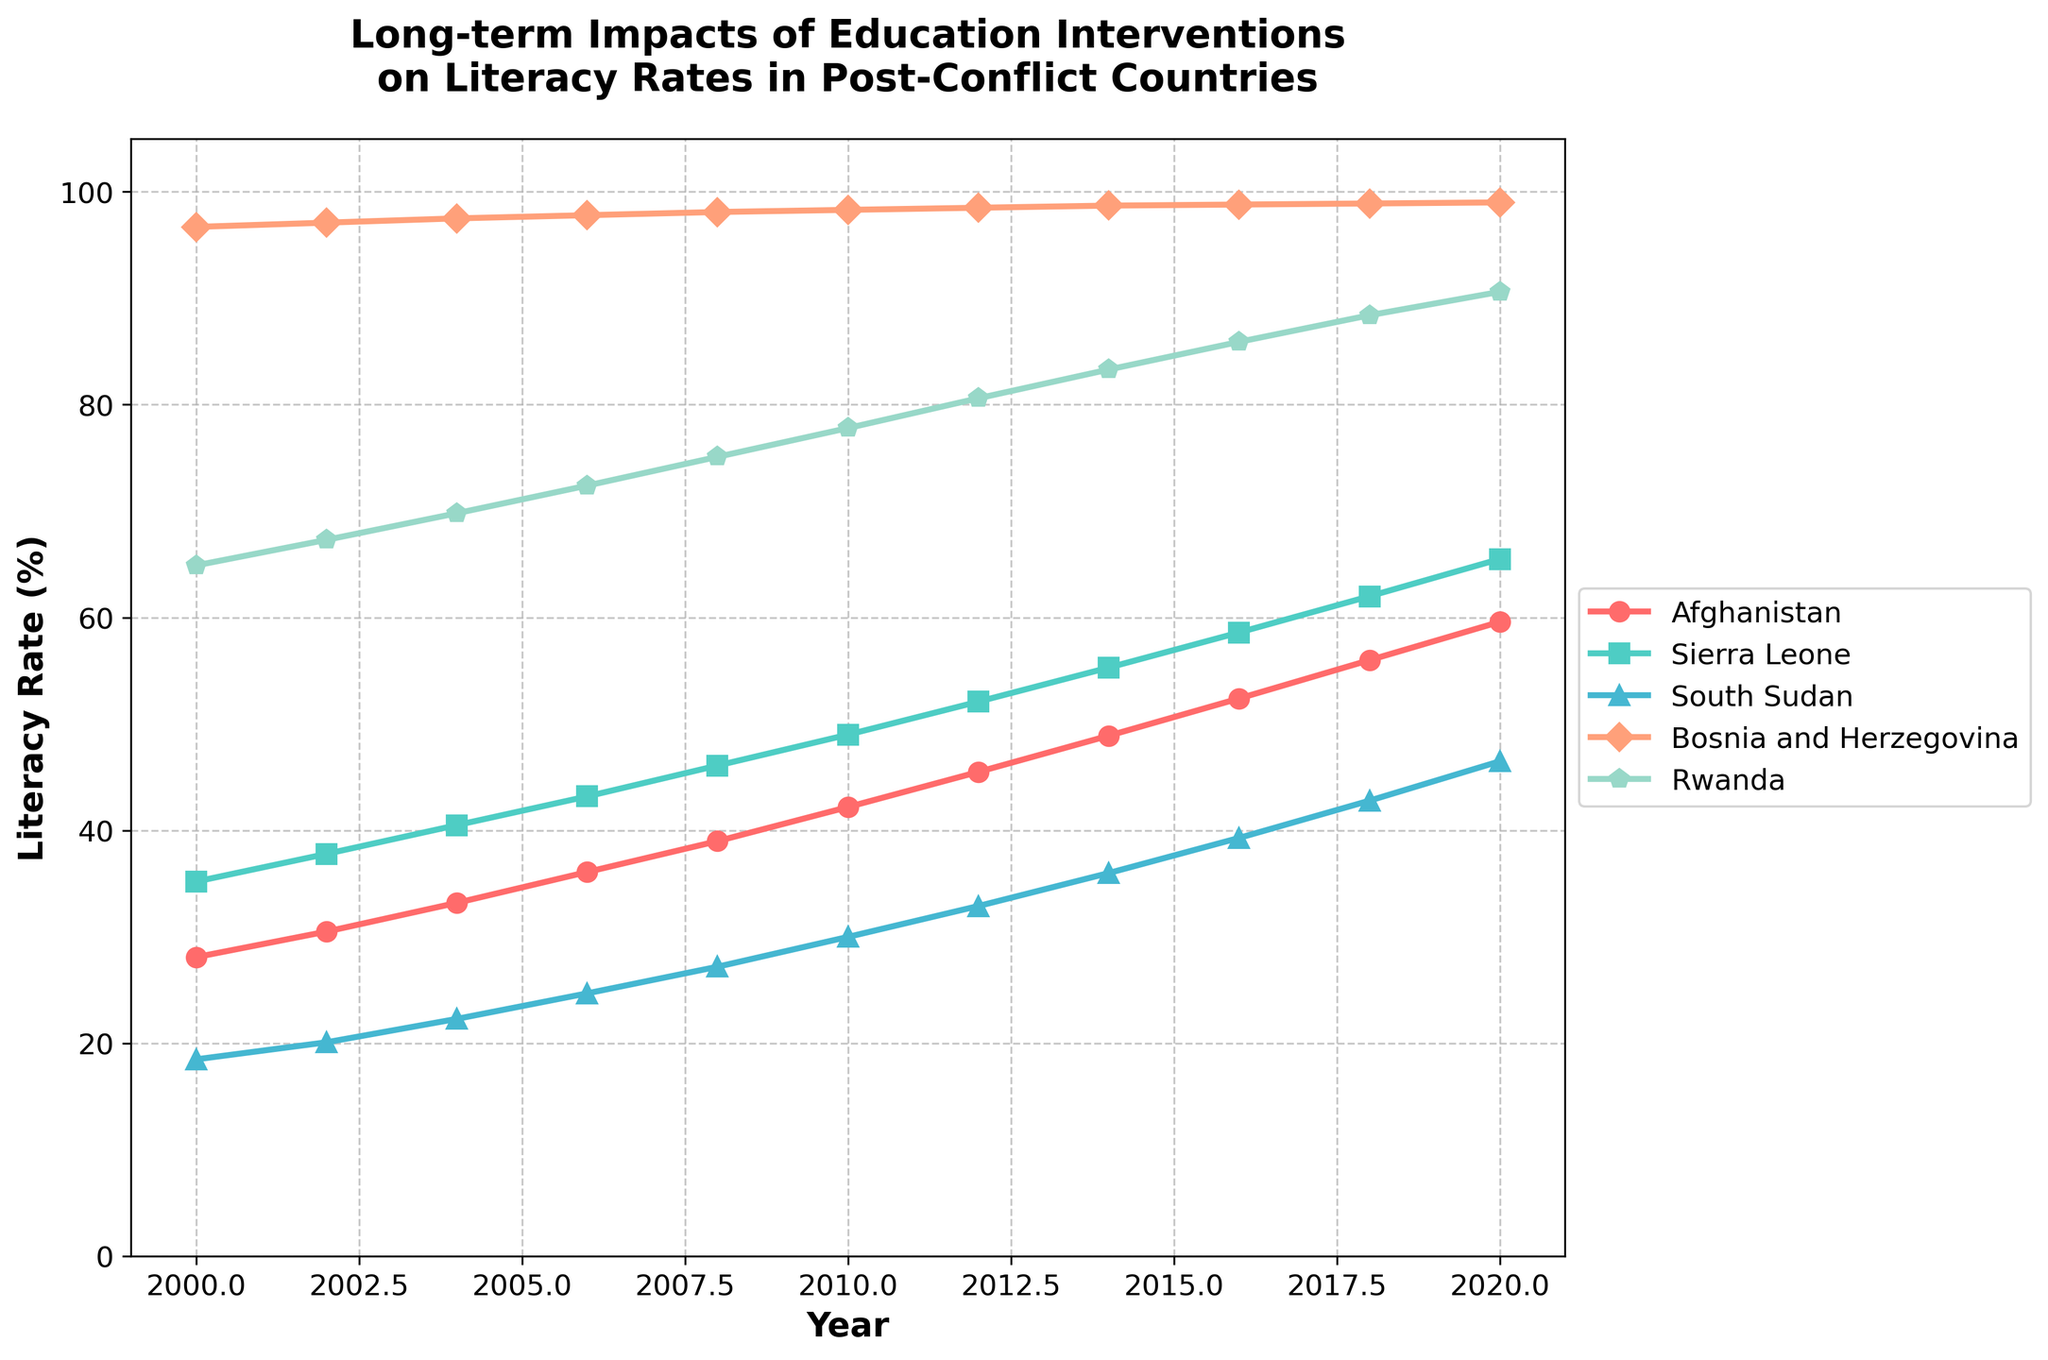What's the overall trend of literacy rates in Afghanistan from 2000 to 2020? The literacy rate in Afghanistan shows a clear upward trend from 2000 to 2020. Starting at 28.1% in 2000, it steadily increases to 59.6% in 2020. This indicates significant improvements in education over the 20 years.
Answer: Upward trend Which country had the highest literacy rate in 2000? In 2000, Bosnia and Herzegovina had the highest literacy rate among the five countries, with a value of 96.7%. By visually inspecting the figure, this value is the highest on the y-axis.
Answer: Bosnia and Herzegovina Compare the literacy rates of Rwanda and Afghanistan in 2020. Which country saw a larger increase from 2000 to 2020? Calculate the difference for each country. In 2000, Rwanda had a literacy rate of 64.9%, which increased to 90.6% in 2020. This is an increase of 25.7%. Afghanistan's literacy rate increased from 28.1% in 2000 to 59.6% in 2020, which is an increase of 31.5%. Hence, Afghanistan saw a larger increase.
Answer: Afghanistan Between which two consecutive years did Sierra Leone see the largest jump in literacy rates? Sierra Leone witnessed the largest increase in literacy rates between 2018 and 2020, where the rate increased from 62.0% to 65.5%, a difference of 3.5%. This can be determined by finding the largest difference in the figure for Sierra Leone's line.
Answer: 2018-2020 What is the approximate average literacy rate in 2020 for all five countries combined? To find the average literacy rate in 2020 for all five countries, add the literacy rates and divide by the number of countries: (59.6 + 65.5 + 46.5 + 99.0 + 90.6) / 5 = 72.24%.
Answer: 72.24% Which country consistently had the lowest literacy rate throughout the 20-year period? South Sudan had the lowest literacy rate throughout the 20-year period, starting at 18.5% in 2000 and increasing to 46.5% in 2020. This can be observed by visually inspecting the figure and identifying the consistently lowest line.
Answer: South Sudan How does the increase in literacy rates for Bosnia and Herzegovina compare to other countries over the 20 years? Bosnia and Herzegovina had the smallest rate of increase in literacy rates from 96.7% in 2000 to 99.0% in 2020, a difference of only 2.3%. In contrast, other countries saw much larger increases. This can be verified by comparing the slopes of the lines in the figure.
Answer: Smallest increase Identify the year when Rwanda surpassed an 80% literacy rate. Rwanda surpassed an 80% literacy rate in 2012, as indicated by the point on the figure where the line crosses the 80% mark.
Answer: 2012 